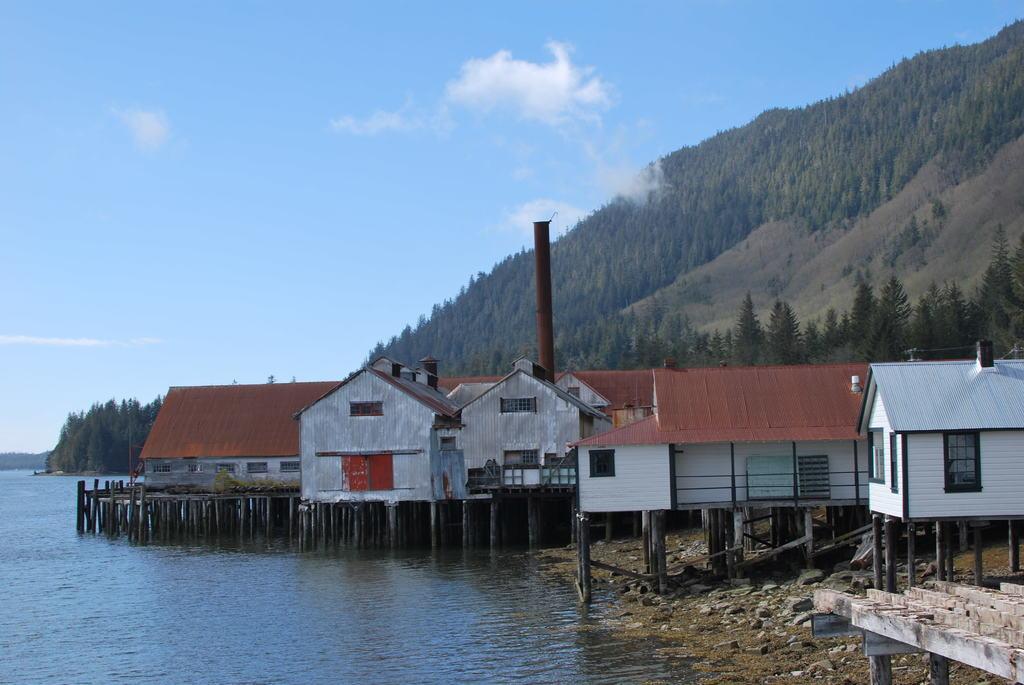Can you describe this image briefly? In the center of the image we can see the houses, roofs, windows, logs, pole. In the background of the image we can see the hills, trees, water. At the top of the image we can see the clouds are present in the sky. On the right side of the image we can see the stones. 